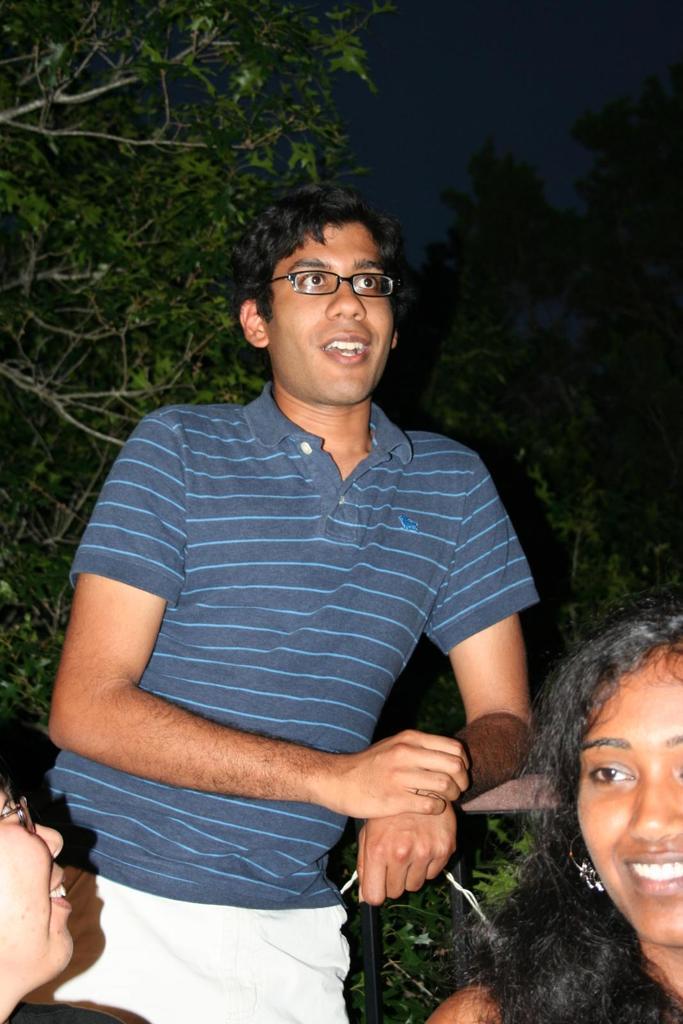In one or two sentences, can you explain what this image depicts? A man is standing, he wore t-shirt, short, spectacles and smiling. On the right side there is a girl smiling, on the left side there are trees in this image. 